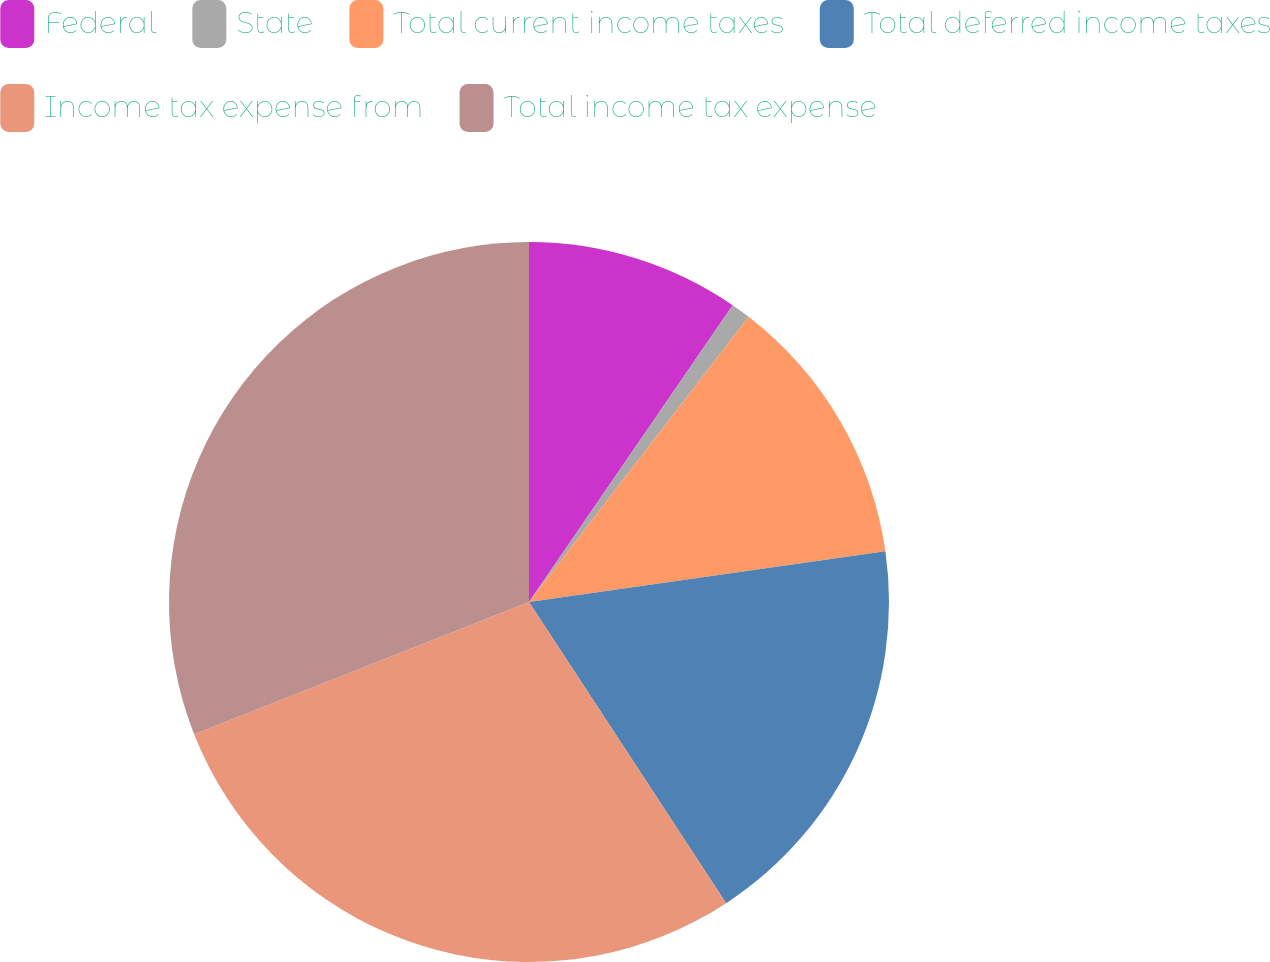<chart> <loc_0><loc_0><loc_500><loc_500><pie_chart><fcel>Federal<fcel>State<fcel>Total current income taxes<fcel>Total deferred income taxes<fcel>Income tax expense from<fcel>Total income tax expense<nl><fcel>9.57%<fcel>0.87%<fcel>12.31%<fcel>18.02%<fcel>28.24%<fcel>30.98%<nl></chart> 